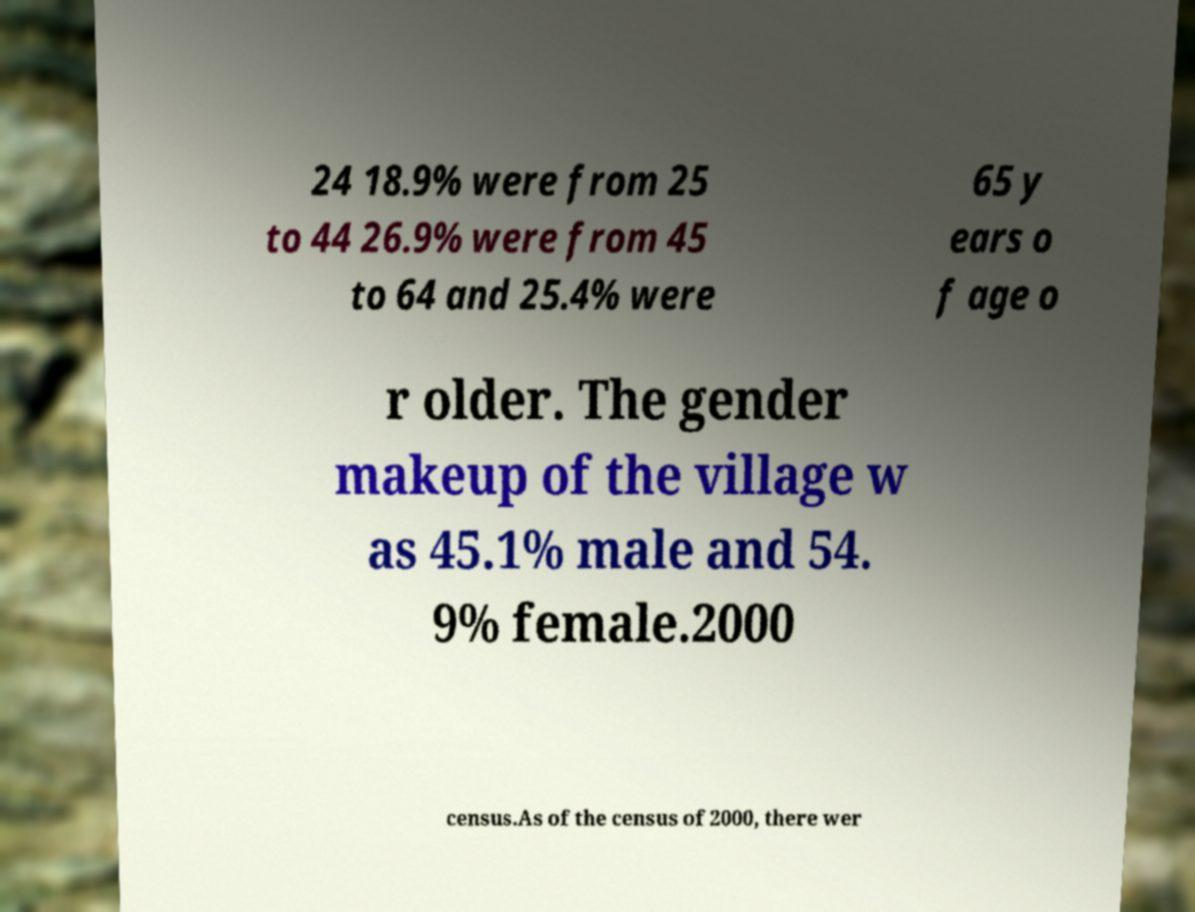Can you accurately transcribe the text from the provided image for me? 24 18.9% were from 25 to 44 26.9% were from 45 to 64 and 25.4% were 65 y ears o f age o r older. The gender makeup of the village w as 45.1% male and 54. 9% female.2000 census.As of the census of 2000, there wer 